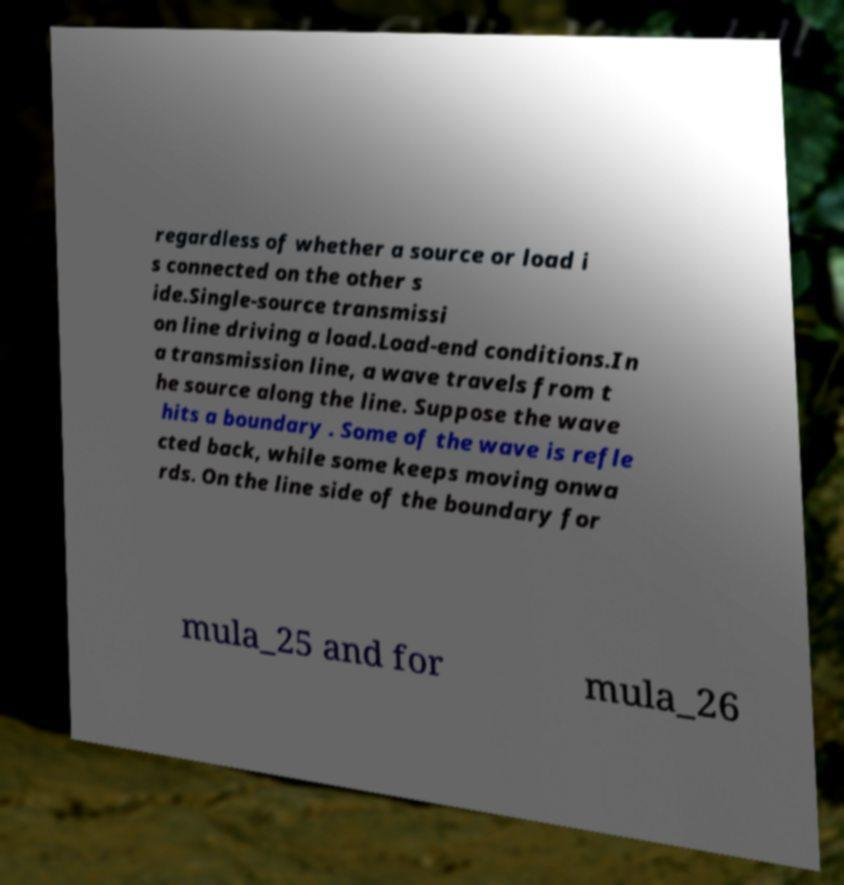Please read and relay the text visible in this image. What does it say? regardless of whether a source or load i s connected on the other s ide.Single-source transmissi on line driving a load.Load-end conditions.In a transmission line, a wave travels from t he source along the line. Suppose the wave hits a boundary . Some of the wave is refle cted back, while some keeps moving onwa rds. On the line side of the boundary for mula_25 and for mula_26 